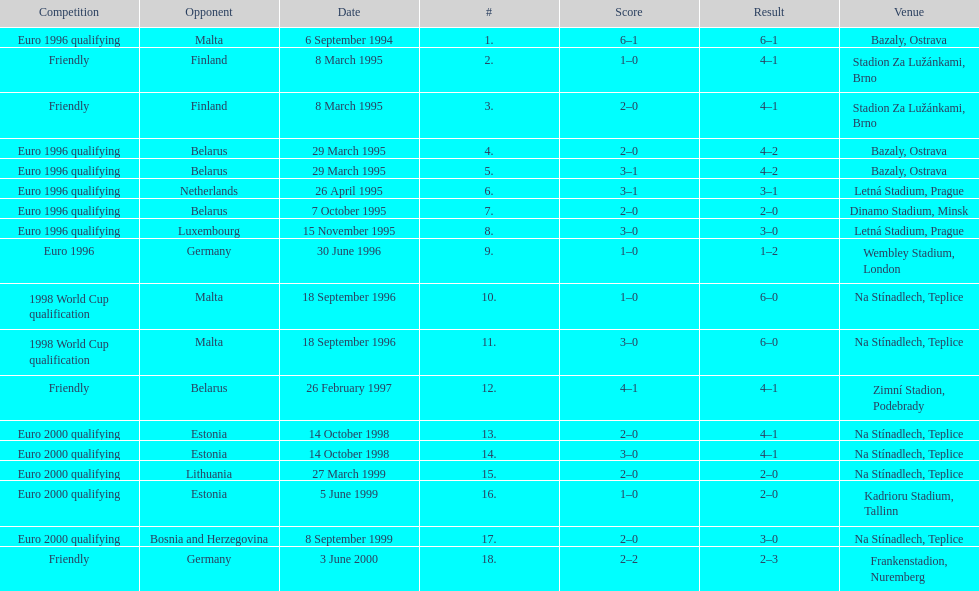Could you help me parse every detail presented in this table? {'header': ['Competition', 'Opponent', 'Date', '#', 'Score', 'Result', 'Venue'], 'rows': [['Euro 1996 qualifying', 'Malta', '6 September 1994', '1.', '6–1', '6–1', 'Bazaly, Ostrava'], ['Friendly', 'Finland', '8 March 1995', '2.', '1–0', '4–1', 'Stadion Za Lužánkami, Brno'], ['Friendly', 'Finland', '8 March 1995', '3.', '2–0', '4–1', 'Stadion Za Lužánkami, Brno'], ['Euro 1996 qualifying', 'Belarus', '29 March 1995', '4.', '2–0', '4–2', 'Bazaly, Ostrava'], ['Euro 1996 qualifying', 'Belarus', '29 March 1995', '5.', '3–1', '4–2', 'Bazaly, Ostrava'], ['Euro 1996 qualifying', 'Netherlands', '26 April 1995', '6.', '3–1', '3–1', 'Letná Stadium, Prague'], ['Euro 1996 qualifying', 'Belarus', '7 October 1995', '7.', '2–0', '2–0', 'Dinamo Stadium, Minsk'], ['Euro 1996 qualifying', 'Luxembourg', '15 November 1995', '8.', '3–0', '3–0', 'Letná Stadium, Prague'], ['Euro 1996', 'Germany', '30 June 1996', '9.', '1–0', '1–2', 'Wembley Stadium, London'], ['1998 World Cup qualification', 'Malta', '18 September 1996', '10.', '1–0', '6–0', 'Na Stínadlech, Teplice'], ['1998 World Cup qualification', 'Malta', '18 September 1996', '11.', '3–0', '6–0', 'Na Stínadlech, Teplice'], ['Friendly', 'Belarus', '26 February 1997', '12.', '4–1', '4–1', 'Zimní Stadion, Podebrady'], ['Euro 2000 qualifying', 'Estonia', '14 October 1998', '13.', '2–0', '4–1', 'Na Stínadlech, Teplice'], ['Euro 2000 qualifying', 'Estonia', '14 October 1998', '14.', '3–0', '4–1', 'Na Stínadlech, Teplice'], ['Euro 2000 qualifying', 'Lithuania', '27 March 1999', '15.', '2–0', '2–0', 'Na Stínadlech, Teplice'], ['Euro 2000 qualifying', 'Estonia', '5 June 1999', '16.', '1–0', '2–0', 'Kadrioru Stadium, Tallinn'], ['Euro 2000 qualifying', 'Bosnia and Herzegovina', '8 September 1999', '17.', '2–0', '3–0', 'Na Stínadlech, Teplice'], ['Friendly', 'Germany', '3 June 2000', '18.', '2–2', '2–3', 'Frankenstadion, Nuremberg']]} What was the number of times czech republic played against germany? 2. 